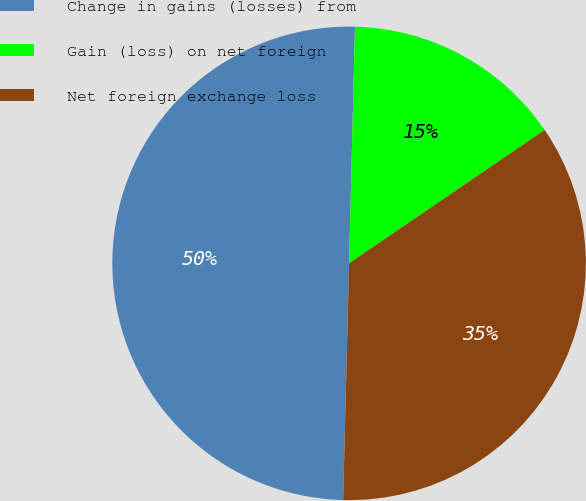<chart> <loc_0><loc_0><loc_500><loc_500><pie_chart><fcel>Change in gains (losses) from<fcel>Gain (loss) on net foreign<fcel>Net foreign exchange loss<nl><fcel>50.0%<fcel>15.07%<fcel>34.93%<nl></chart> 